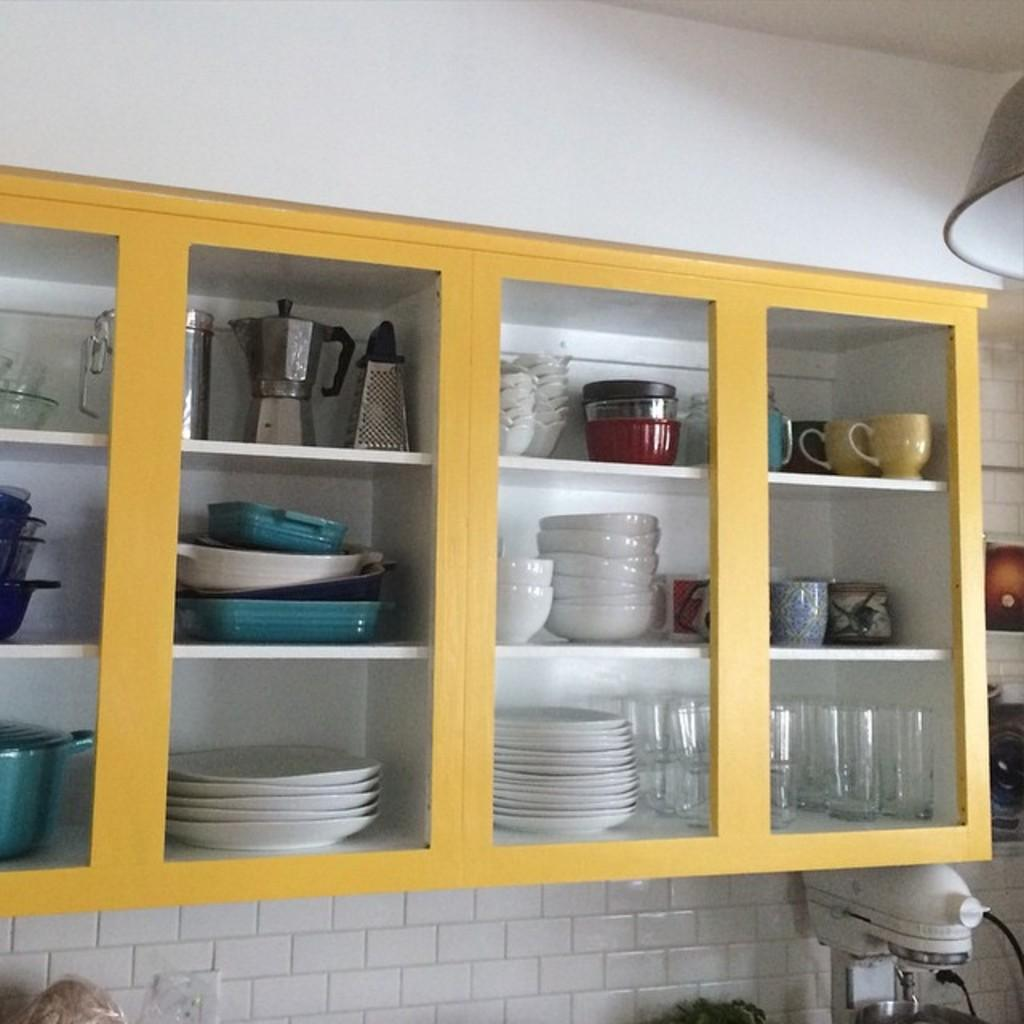What type of storage or display feature is present in the image? There are shelves in the image. What items can be seen on the shelves? There are utensils on the shelves. What can be seen in the background of the image? There is a wall visible in the background of the image. How many children are playing with a bottle and a foot in the image? There are no children, bottles, or feet present in the image. 